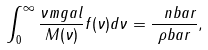Convert formula to latex. <formula><loc_0><loc_0><loc_500><loc_500>\int _ { 0 } ^ { \infty } \frac { \nu m g a l } { M ( \nu ) } f ( \nu ) d \nu = \frac { \ n b a r } { \rho b a r } ,</formula> 